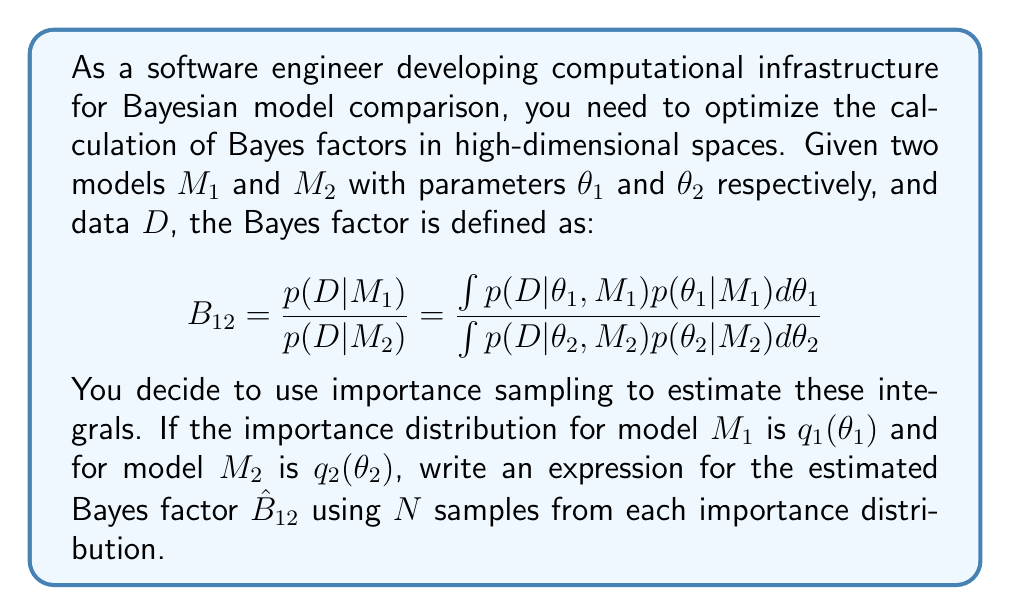What is the answer to this math problem? To solve this problem, we'll follow these steps:

1) Recall the importance sampling estimator for an integral:
   $$\int f(x)dx \approx \frac{1}{N}\sum_{i=1}^N \frac{f(x_i)}{q(x_i)}, \quad x_i \sim q(x)$$

2) For the numerator (evidence of $M_1$), we apply this to get:
   $$p(D|M_1) \approx \frac{1}{N}\sum_{i=1}^N \frac{p(D|\theta_{1i},M_1)p(\theta_{1i}|M_1)}{q_1(\theta_{1i})}, \quad \theta_{1i} \sim q_1(\theta_1)$$

3) Similarly for the denominator (evidence of $M_2$):
   $$p(D|M_2) \approx \frac{1}{N}\sum_{i=1}^N \frac{p(D|\theta_{2i},M_2)p(\theta_{2i}|M_2)}{q_2(\theta_{2i})}, \quad \theta_{2i} \sim q_2(\theta_2)$$

4) The Bayes factor estimate is the ratio of these two estimates:

   $$\hat{B}_{12} = \frac{\frac{1}{N}\sum_{i=1}^N \frac{p(D|\theta_{1i},M_1)p(\theta_{1i}|M_1)}{q_1(\theta_{1i})}}{\frac{1}{N}\sum_{i=1}^N \frac{p(D|\theta_{2i},M_2)p(\theta_{2i}|M_2)}{q_2(\theta_{2i})}}$$

5) The $\frac{1}{N}$ terms cancel out, giving us the final expression:

   $$\hat{B}_{12} = \frac{\sum_{i=1}^N \frac{p(D|\theta_{1i},M_1)p(\theta_{1i}|M_1)}{q_1(\theta_{1i})}}{\sum_{i=1}^N \frac{p(D|\theta_{2i},M_2)p(\theta_{2i}|M_2)}{q_2(\theta_{2i})}}$$

This estimator allows for efficient computation of Bayes factors in high-dimensional spaces, as it avoids the need for direct integration over the entire parameter space.
Answer: $$\hat{B}_{12} = \frac{\sum_{i=1}^N \frac{p(D|\theta_{1i},M_1)p(\theta_{1i}|M_1)}{q_1(\theta_{1i})}}{\sum_{i=1}^N \frac{p(D|\theta_{2i},M_2)p(\theta_{2i}|M_2)}{q_2(\theta_{2i})}}$$ 